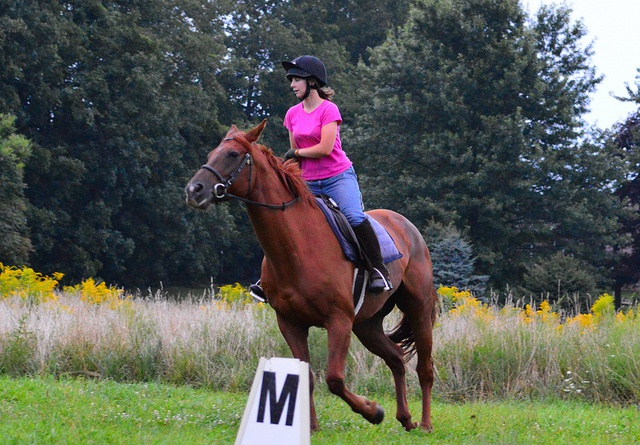Describe the objects in this image and their specific colors. I can see horse in black, maroon, brown, and gray tones and people in black, magenta, navy, and lightpink tones in this image. 